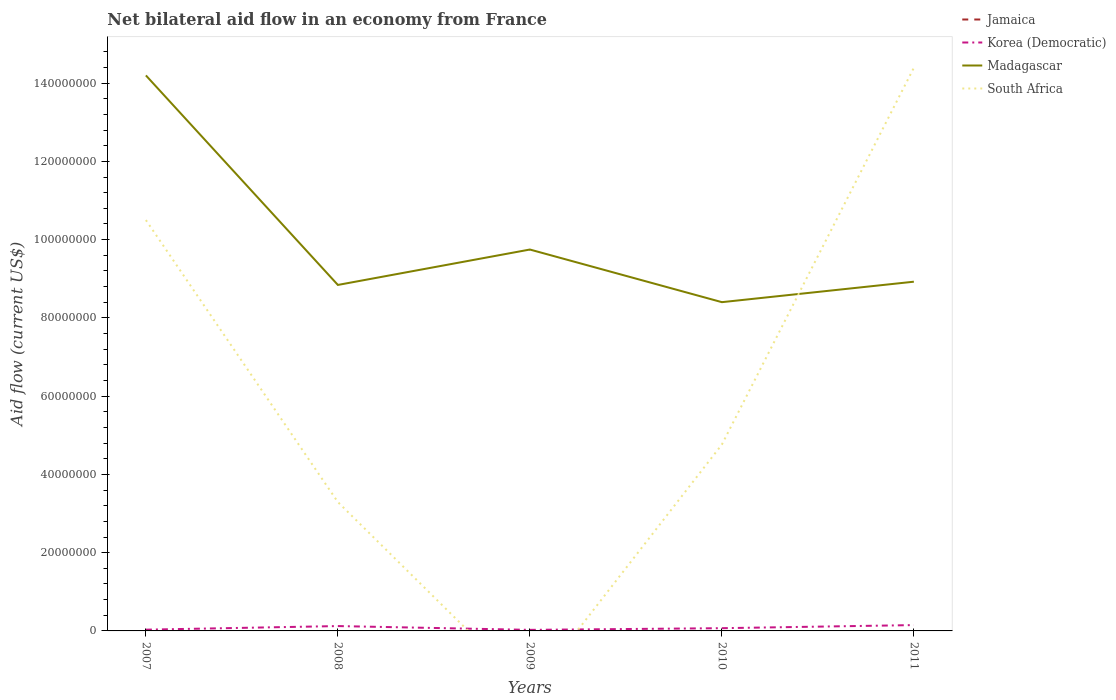Does the line corresponding to Madagascar intersect with the line corresponding to Korea (Democratic)?
Offer a terse response. No. Is the number of lines equal to the number of legend labels?
Offer a very short reply. No. What is the total net bilateral aid flow in Madagascar in the graph?
Provide a succinct answer. 5.80e+07. What is the difference between the highest and the second highest net bilateral aid flow in Korea (Democratic)?
Your response must be concise. 1.22e+06. Is the net bilateral aid flow in South Africa strictly greater than the net bilateral aid flow in Jamaica over the years?
Your answer should be very brief. No. How many lines are there?
Your answer should be compact. 3. How many years are there in the graph?
Offer a terse response. 5. Are the values on the major ticks of Y-axis written in scientific E-notation?
Provide a succinct answer. No. Does the graph contain any zero values?
Keep it short and to the point. Yes. How many legend labels are there?
Provide a short and direct response. 4. What is the title of the graph?
Provide a succinct answer. Net bilateral aid flow in an economy from France. What is the label or title of the X-axis?
Your response must be concise. Years. What is the Aid flow (current US$) of Jamaica in 2007?
Your response must be concise. 0. What is the Aid flow (current US$) in Madagascar in 2007?
Ensure brevity in your answer.  1.42e+08. What is the Aid flow (current US$) of South Africa in 2007?
Provide a succinct answer. 1.05e+08. What is the Aid flow (current US$) in Jamaica in 2008?
Your answer should be compact. 0. What is the Aid flow (current US$) of Korea (Democratic) in 2008?
Offer a very short reply. 1.24e+06. What is the Aid flow (current US$) of Madagascar in 2008?
Make the answer very short. 8.84e+07. What is the Aid flow (current US$) of South Africa in 2008?
Your response must be concise. 3.29e+07. What is the Aid flow (current US$) in Madagascar in 2009?
Ensure brevity in your answer.  9.75e+07. What is the Aid flow (current US$) in Jamaica in 2010?
Keep it short and to the point. 0. What is the Aid flow (current US$) of Madagascar in 2010?
Offer a terse response. 8.40e+07. What is the Aid flow (current US$) of South Africa in 2010?
Keep it short and to the point. 4.76e+07. What is the Aid flow (current US$) in Jamaica in 2011?
Your answer should be very brief. 0. What is the Aid flow (current US$) in Korea (Democratic) in 2011?
Your answer should be very brief. 1.49e+06. What is the Aid flow (current US$) in Madagascar in 2011?
Your answer should be compact. 8.92e+07. What is the Aid flow (current US$) in South Africa in 2011?
Keep it short and to the point. 1.44e+08. Across all years, what is the maximum Aid flow (current US$) of Korea (Democratic)?
Keep it short and to the point. 1.49e+06. Across all years, what is the maximum Aid flow (current US$) in Madagascar?
Make the answer very short. 1.42e+08. Across all years, what is the maximum Aid flow (current US$) in South Africa?
Your answer should be compact. 1.44e+08. Across all years, what is the minimum Aid flow (current US$) in Madagascar?
Offer a terse response. 8.40e+07. Across all years, what is the minimum Aid flow (current US$) of South Africa?
Provide a succinct answer. 0. What is the total Aid flow (current US$) in Korea (Democratic) in the graph?
Give a very brief answer. 4.02e+06. What is the total Aid flow (current US$) of Madagascar in the graph?
Provide a short and direct response. 5.01e+08. What is the total Aid flow (current US$) of South Africa in the graph?
Offer a terse response. 3.29e+08. What is the difference between the Aid flow (current US$) of Korea (Democratic) in 2007 and that in 2008?
Give a very brief answer. -9.20e+05. What is the difference between the Aid flow (current US$) in Madagascar in 2007 and that in 2008?
Give a very brief answer. 5.36e+07. What is the difference between the Aid flow (current US$) in South Africa in 2007 and that in 2008?
Offer a terse response. 7.21e+07. What is the difference between the Aid flow (current US$) of Madagascar in 2007 and that in 2009?
Provide a succinct answer. 4.45e+07. What is the difference between the Aid flow (current US$) in Korea (Democratic) in 2007 and that in 2010?
Your answer should be compact. -3.80e+05. What is the difference between the Aid flow (current US$) in Madagascar in 2007 and that in 2010?
Offer a terse response. 5.80e+07. What is the difference between the Aid flow (current US$) of South Africa in 2007 and that in 2010?
Offer a terse response. 5.74e+07. What is the difference between the Aid flow (current US$) in Korea (Democratic) in 2007 and that in 2011?
Your answer should be compact. -1.17e+06. What is the difference between the Aid flow (current US$) in Madagascar in 2007 and that in 2011?
Provide a succinct answer. 5.27e+07. What is the difference between the Aid flow (current US$) of South Africa in 2007 and that in 2011?
Ensure brevity in your answer.  -3.89e+07. What is the difference between the Aid flow (current US$) of Korea (Democratic) in 2008 and that in 2009?
Provide a succinct answer. 9.70e+05. What is the difference between the Aid flow (current US$) of Madagascar in 2008 and that in 2009?
Make the answer very short. -9.05e+06. What is the difference between the Aid flow (current US$) in Korea (Democratic) in 2008 and that in 2010?
Make the answer very short. 5.40e+05. What is the difference between the Aid flow (current US$) of Madagascar in 2008 and that in 2010?
Provide a short and direct response. 4.40e+06. What is the difference between the Aid flow (current US$) in South Africa in 2008 and that in 2010?
Your answer should be very brief. -1.47e+07. What is the difference between the Aid flow (current US$) of Korea (Democratic) in 2008 and that in 2011?
Ensure brevity in your answer.  -2.50e+05. What is the difference between the Aid flow (current US$) of Madagascar in 2008 and that in 2011?
Offer a terse response. -8.30e+05. What is the difference between the Aid flow (current US$) in South Africa in 2008 and that in 2011?
Offer a terse response. -1.11e+08. What is the difference between the Aid flow (current US$) in Korea (Democratic) in 2009 and that in 2010?
Keep it short and to the point. -4.30e+05. What is the difference between the Aid flow (current US$) in Madagascar in 2009 and that in 2010?
Keep it short and to the point. 1.34e+07. What is the difference between the Aid flow (current US$) of Korea (Democratic) in 2009 and that in 2011?
Your answer should be very brief. -1.22e+06. What is the difference between the Aid flow (current US$) in Madagascar in 2009 and that in 2011?
Provide a short and direct response. 8.22e+06. What is the difference between the Aid flow (current US$) in Korea (Democratic) in 2010 and that in 2011?
Provide a short and direct response. -7.90e+05. What is the difference between the Aid flow (current US$) in Madagascar in 2010 and that in 2011?
Ensure brevity in your answer.  -5.23e+06. What is the difference between the Aid flow (current US$) of South Africa in 2010 and that in 2011?
Ensure brevity in your answer.  -9.63e+07. What is the difference between the Aid flow (current US$) of Korea (Democratic) in 2007 and the Aid flow (current US$) of Madagascar in 2008?
Keep it short and to the point. -8.81e+07. What is the difference between the Aid flow (current US$) in Korea (Democratic) in 2007 and the Aid flow (current US$) in South Africa in 2008?
Your answer should be compact. -3.26e+07. What is the difference between the Aid flow (current US$) in Madagascar in 2007 and the Aid flow (current US$) in South Africa in 2008?
Your answer should be very brief. 1.09e+08. What is the difference between the Aid flow (current US$) in Korea (Democratic) in 2007 and the Aid flow (current US$) in Madagascar in 2009?
Provide a short and direct response. -9.72e+07. What is the difference between the Aid flow (current US$) in Korea (Democratic) in 2007 and the Aid flow (current US$) in Madagascar in 2010?
Ensure brevity in your answer.  -8.37e+07. What is the difference between the Aid flow (current US$) of Korea (Democratic) in 2007 and the Aid flow (current US$) of South Africa in 2010?
Provide a short and direct response. -4.73e+07. What is the difference between the Aid flow (current US$) in Madagascar in 2007 and the Aid flow (current US$) in South Africa in 2010?
Your response must be concise. 9.43e+07. What is the difference between the Aid flow (current US$) of Korea (Democratic) in 2007 and the Aid flow (current US$) of Madagascar in 2011?
Your response must be concise. -8.89e+07. What is the difference between the Aid flow (current US$) of Korea (Democratic) in 2007 and the Aid flow (current US$) of South Africa in 2011?
Your response must be concise. -1.44e+08. What is the difference between the Aid flow (current US$) in Madagascar in 2007 and the Aid flow (current US$) in South Africa in 2011?
Ensure brevity in your answer.  -1.95e+06. What is the difference between the Aid flow (current US$) of Korea (Democratic) in 2008 and the Aid flow (current US$) of Madagascar in 2009?
Keep it short and to the point. -9.62e+07. What is the difference between the Aid flow (current US$) of Korea (Democratic) in 2008 and the Aid flow (current US$) of Madagascar in 2010?
Provide a succinct answer. -8.28e+07. What is the difference between the Aid flow (current US$) in Korea (Democratic) in 2008 and the Aid flow (current US$) in South Africa in 2010?
Give a very brief answer. -4.64e+07. What is the difference between the Aid flow (current US$) in Madagascar in 2008 and the Aid flow (current US$) in South Africa in 2010?
Ensure brevity in your answer.  4.08e+07. What is the difference between the Aid flow (current US$) of Korea (Democratic) in 2008 and the Aid flow (current US$) of Madagascar in 2011?
Your answer should be compact. -8.80e+07. What is the difference between the Aid flow (current US$) of Korea (Democratic) in 2008 and the Aid flow (current US$) of South Africa in 2011?
Offer a very short reply. -1.43e+08. What is the difference between the Aid flow (current US$) of Madagascar in 2008 and the Aid flow (current US$) of South Africa in 2011?
Make the answer very short. -5.55e+07. What is the difference between the Aid flow (current US$) of Korea (Democratic) in 2009 and the Aid flow (current US$) of Madagascar in 2010?
Give a very brief answer. -8.38e+07. What is the difference between the Aid flow (current US$) of Korea (Democratic) in 2009 and the Aid flow (current US$) of South Africa in 2010?
Ensure brevity in your answer.  -4.74e+07. What is the difference between the Aid flow (current US$) of Madagascar in 2009 and the Aid flow (current US$) of South Africa in 2010?
Your answer should be very brief. 4.98e+07. What is the difference between the Aid flow (current US$) in Korea (Democratic) in 2009 and the Aid flow (current US$) in Madagascar in 2011?
Provide a short and direct response. -8.90e+07. What is the difference between the Aid flow (current US$) in Korea (Democratic) in 2009 and the Aid flow (current US$) in South Africa in 2011?
Keep it short and to the point. -1.44e+08. What is the difference between the Aid flow (current US$) of Madagascar in 2009 and the Aid flow (current US$) of South Africa in 2011?
Keep it short and to the point. -4.64e+07. What is the difference between the Aid flow (current US$) in Korea (Democratic) in 2010 and the Aid flow (current US$) in Madagascar in 2011?
Your response must be concise. -8.86e+07. What is the difference between the Aid flow (current US$) of Korea (Democratic) in 2010 and the Aid flow (current US$) of South Africa in 2011?
Your answer should be compact. -1.43e+08. What is the difference between the Aid flow (current US$) in Madagascar in 2010 and the Aid flow (current US$) in South Africa in 2011?
Keep it short and to the point. -5.99e+07. What is the average Aid flow (current US$) in Jamaica per year?
Ensure brevity in your answer.  0. What is the average Aid flow (current US$) of Korea (Democratic) per year?
Offer a terse response. 8.04e+05. What is the average Aid flow (current US$) of Madagascar per year?
Provide a short and direct response. 1.00e+08. What is the average Aid flow (current US$) in South Africa per year?
Give a very brief answer. 6.59e+07. In the year 2007, what is the difference between the Aid flow (current US$) in Korea (Democratic) and Aid flow (current US$) in Madagascar?
Offer a very short reply. -1.42e+08. In the year 2007, what is the difference between the Aid flow (current US$) in Korea (Democratic) and Aid flow (current US$) in South Africa?
Offer a terse response. -1.05e+08. In the year 2007, what is the difference between the Aid flow (current US$) in Madagascar and Aid flow (current US$) in South Africa?
Your response must be concise. 3.70e+07. In the year 2008, what is the difference between the Aid flow (current US$) of Korea (Democratic) and Aid flow (current US$) of Madagascar?
Offer a very short reply. -8.72e+07. In the year 2008, what is the difference between the Aid flow (current US$) of Korea (Democratic) and Aid flow (current US$) of South Africa?
Provide a short and direct response. -3.17e+07. In the year 2008, what is the difference between the Aid flow (current US$) of Madagascar and Aid flow (current US$) of South Africa?
Keep it short and to the point. 5.55e+07. In the year 2009, what is the difference between the Aid flow (current US$) in Korea (Democratic) and Aid flow (current US$) in Madagascar?
Give a very brief answer. -9.72e+07. In the year 2010, what is the difference between the Aid flow (current US$) of Korea (Democratic) and Aid flow (current US$) of Madagascar?
Your response must be concise. -8.33e+07. In the year 2010, what is the difference between the Aid flow (current US$) of Korea (Democratic) and Aid flow (current US$) of South Africa?
Your response must be concise. -4.69e+07. In the year 2010, what is the difference between the Aid flow (current US$) of Madagascar and Aid flow (current US$) of South Africa?
Give a very brief answer. 3.64e+07. In the year 2011, what is the difference between the Aid flow (current US$) of Korea (Democratic) and Aid flow (current US$) of Madagascar?
Your answer should be compact. -8.78e+07. In the year 2011, what is the difference between the Aid flow (current US$) in Korea (Democratic) and Aid flow (current US$) in South Africa?
Provide a succinct answer. -1.42e+08. In the year 2011, what is the difference between the Aid flow (current US$) of Madagascar and Aid flow (current US$) of South Africa?
Ensure brevity in your answer.  -5.47e+07. What is the ratio of the Aid flow (current US$) in Korea (Democratic) in 2007 to that in 2008?
Ensure brevity in your answer.  0.26. What is the ratio of the Aid flow (current US$) of Madagascar in 2007 to that in 2008?
Give a very brief answer. 1.61. What is the ratio of the Aid flow (current US$) in South Africa in 2007 to that in 2008?
Provide a succinct answer. 3.19. What is the ratio of the Aid flow (current US$) of Korea (Democratic) in 2007 to that in 2009?
Your answer should be very brief. 1.19. What is the ratio of the Aid flow (current US$) in Madagascar in 2007 to that in 2009?
Your answer should be very brief. 1.46. What is the ratio of the Aid flow (current US$) of Korea (Democratic) in 2007 to that in 2010?
Give a very brief answer. 0.46. What is the ratio of the Aid flow (current US$) of Madagascar in 2007 to that in 2010?
Your response must be concise. 1.69. What is the ratio of the Aid flow (current US$) in South Africa in 2007 to that in 2010?
Your answer should be very brief. 2.2. What is the ratio of the Aid flow (current US$) of Korea (Democratic) in 2007 to that in 2011?
Your answer should be compact. 0.21. What is the ratio of the Aid flow (current US$) in Madagascar in 2007 to that in 2011?
Keep it short and to the point. 1.59. What is the ratio of the Aid flow (current US$) in South Africa in 2007 to that in 2011?
Make the answer very short. 0.73. What is the ratio of the Aid flow (current US$) in Korea (Democratic) in 2008 to that in 2009?
Keep it short and to the point. 4.59. What is the ratio of the Aid flow (current US$) in Madagascar in 2008 to that in 2009?
Your answer should be compact. 0.91. What is the ratio of the Aid flow (current US$) of Korea (Democratic) in 2008 to that in 2010?
Provide a succinct answer. 1.77. What is the ratio of the Aid flow (current US$) in Madagascar in 2008 to that in 2010?
Give a very brief answer. 1.05. What is the ratio of the Aid flow (current US$) in South Africa in 2008 to that in 2010?
Ensure brevity in your answer.  0.69. What is the ratio of the Aid flow (current US$) in Korea (Democratic) in 2008 to that in 2011?
Make the answer very short. 0.83. What is the ratio of the Aid flow (current US$) of South Africa in 2008 to that in 2011?
Your answer should be very brief. 0.23. What is the ratio of the Aid flow (current US$) of Korea (Democratic) in 2009 to that in 2010?
Provide a succinct answer. 0.39. What is the ratio of the Aid flow (current US$) of Madagascar in 2009 to that in 2010?
Offer a terse response. 1.16. What is the ratio of the Aid flow (current US$) in Korea (Democratic) in 2009 to that in 2011?
Offer a terse response. 0.18. What is the ratio of the Aid flow (current US$) of Madagascar in 2009 to that in 2011?
Your response must be concise. 1.09. What is the ratio of the Aid flow (current US$) of Korea (Democratic) in 2010 to that in 2011?
Provide a succinct answer. 0.47. What is the ratio of the Aid flow (current US$) of Madagascar in 2010 to that in 2011?
Your answer should be very brief. 0.94. What is the ratio of the Aid flow (current US$) of South Africa in 2010 to that in 2011?
Offer a very short reply. 0.33. What is the difference between the highest and the second highest Aid flow (current US$) in Korea (Democratic)?
Keep it short and to the point. 2.50e+05. What is the difference between the highest and the second highest Aid flow (current US$) in Madagascar?
Offer a very short reply. 4.45e+07. What is the difference between the highest and the second highest Aid flow (current US$) in South Africa?
Your answer should be very brief. 3.89e+07. What is the difference between the highest and the lowest Aid flow (current US$) of Korea (Democratic)?
Provide a short and direct response. 1.22e+06. What is the difference between the highest and the lowest Aid flow (current US$) of Madagascar?
Your answer should be compact. 5.80e+07. What is the difference between the highest and the lowest Aid flow (current US$) of South Africa?
Offer a terse response. 1.44e+08. 